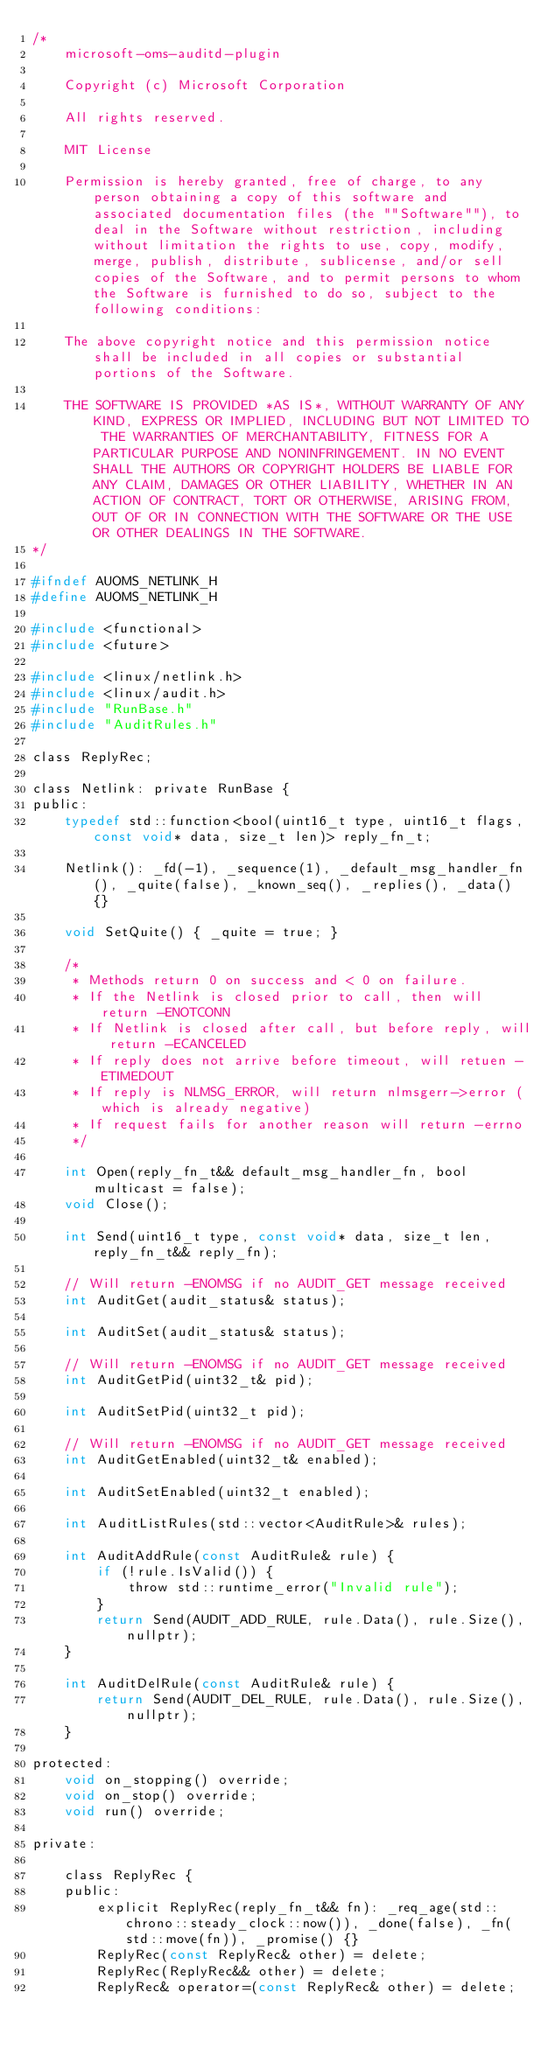<code> <loc_0><loc_0><loc_500><loc_500><_C_>/*
    microsoft-oms-auditd-plugin

    Copyright (c) Microsoft Corporation

    All rights reserved.

    MIT License

    Permission is hereby granted, free of charge, to any person obtaining a copy of this software and associated documentation files (the ""Software""), to deal in the Software without restriction, including without limitation the rights to use, copy, modify, merge, publish, distribute, sublicense, and/or sell copies of the Software, and to permit persons to whom the Software is furnished to do so, subject to the following conditions:

    The above copyright notice and this permission notice shall be included in all copies or substantial portions of the Software.

    THE SOFTWARE IS PROVIDED *AS IS*, WITHOUT WARRANTY OF ANY KIND, EXPRESS OR IMPLIED, INCLUDING BUT NOT LIMITED TO THE WARRANTIES OF MERCHANTABILITY, FITNESS FOR A PARTICULAR PURPOSE AND NONINFRINGEMENT. IN NO EVENT SHALL THE AUTHORS OR COPYRIGHT HOLDERS BE LIABLE FOR ANY CLAIM, DAMAGES OR OTHER LIABILITY, WHETHER IN AN ACTION OF CONTRACT, TORT OR OTHERWISE, ARISING FROM, OUT OF OR IN CONNECTION WITH THE SOFTWARE OR THE USE OR OTHER DEALINGS IN THE SOFTWARE.
*/

#ifndef AUOMS_NETLINK_H
#define AUOMS_NETLINK_H

#include <functional>
#include <future>

#include <linux/netlink.h>
#include <linux/audit.h>
#include "RunBase.h"
#include "AuditRules.h"

class ReplyRec;

class Netlink: private RunBase {
public:
    typedef std::function<bool(uint16_t type, uint16_t flags, const void* data, size_t len)> reply_fn_t;

    Netlink(): _fd(-1), _sequence(1), _default_msg_handler_fn(), _quite(false), _known_seq(), _replies(), _data() {}

    void SetQuite() { _quite = true; }

    /*
     * Methods return 0 on success and < 0 on failure.
     * If the Netlink is closed prior to call, then will return -ENOTCONN
     * If Netlink is closed after call, but before reply, will return -ECANCELED
     * If reply does not arrive before timeout, will retuen -ETIMEDOUT
     * If reply is NLMSG_ERROR, will return nlmsgerr->error (which is already negative)
     * If request fails for another reason will return -errno
     */

    int Open(reply_fn_t&& default_msg_handler_fn, bool multicast = false);
    void Close();

    int Send(uint16_t type, const void* data, size_t len, reply_fn_t&& reply_fn);

    // Will return -ENOMSG if no AUDIT_GET message received
    int AuditGet(audit_status& status);

    int AuditSet(audit_status& status);

    // Will return -ENOMSG if no AUDIT_GET message received
    int AuditGetPid(uint32_t& pid);

    int AuditSetPid(uint32_t pid);

    // Will return -ENOMSG if no AUDIT_GET message received
    int AuditGetEnabled(uint32_t& enabled);

    int AuditSetEnabled(uint32_t enabled);

    int AuditListRules(std::vector<AuditRule>& rules);

    int AuditAddRule(const AuditRule& rule) {
        if (!rule.IsValid()) {
            throw std::runtime_error("Invalid rule");
        }
        return Send(AUDIT_ADD_RULE, rule.Data(), rule.Size(), nullptr);
    }

    int AuditDelRule(const AuditRule& rule) {
        return Send(AUDIT_DEL_RULE, rule.Data(), rule.Size(), nullptr);
    }

protected:
    void on_stopping() override;
    void on_stop() override;
    void run() override;

private:

    class ReplyRec {
    public:
        explicit ReplyRec(reply_fn_t&& fn): _req_age(std::chrono::steady_clock::now()), _done(false), _fn(std::move(fn)), _promise() {}
        ReplyRec(const ReplyRec& other) = delete;
        ReplyRec(ReplyRec&& other) = delete;
        ReplyRec& operator=(const ReplyRec& other) = delete;</code> 